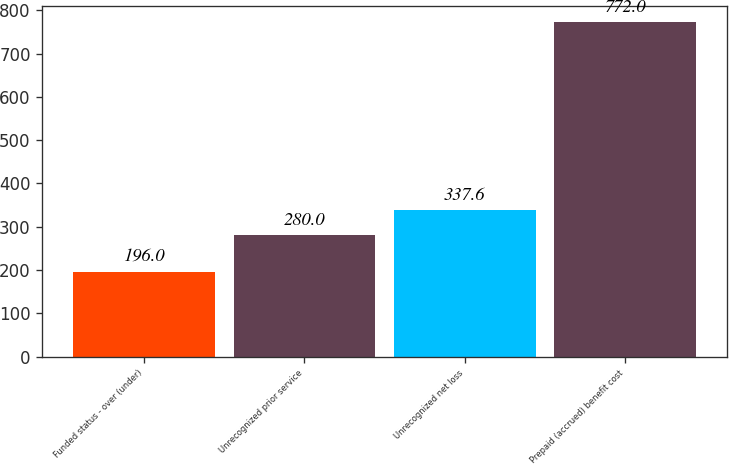Convert chart. <chart><loc_0><loc_0><loc_500><loc_500><bar_chart><fcel>Funded status - over (under)<fcel>Unrecognized prior service<fcel>Unrecognized net loss<fcel>Prepaid (accrued) benefit cost<nl><fcel>196<fcel>280<fcel>337.6<fcel>772<nl></chart> 